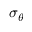<formula> <loc_0><loc_0><loc_500><loc_500>\sigma _ { \theta }</formula> 